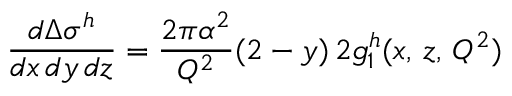Convert formula to latex. <formula><loc_0><loc_0><loc_500><loc_500>\frac { d \Delta \sigma ^ { h } } { d x \, d y \, d z } = \frac { 2 \pi \alpha ^ { 2 } } { Q ^ { 2 } } ( 2 - y ) \, 2 g _ { 1 } ^ { h } ( x , \, z , \, Q ^ { 2 } )</formula> 